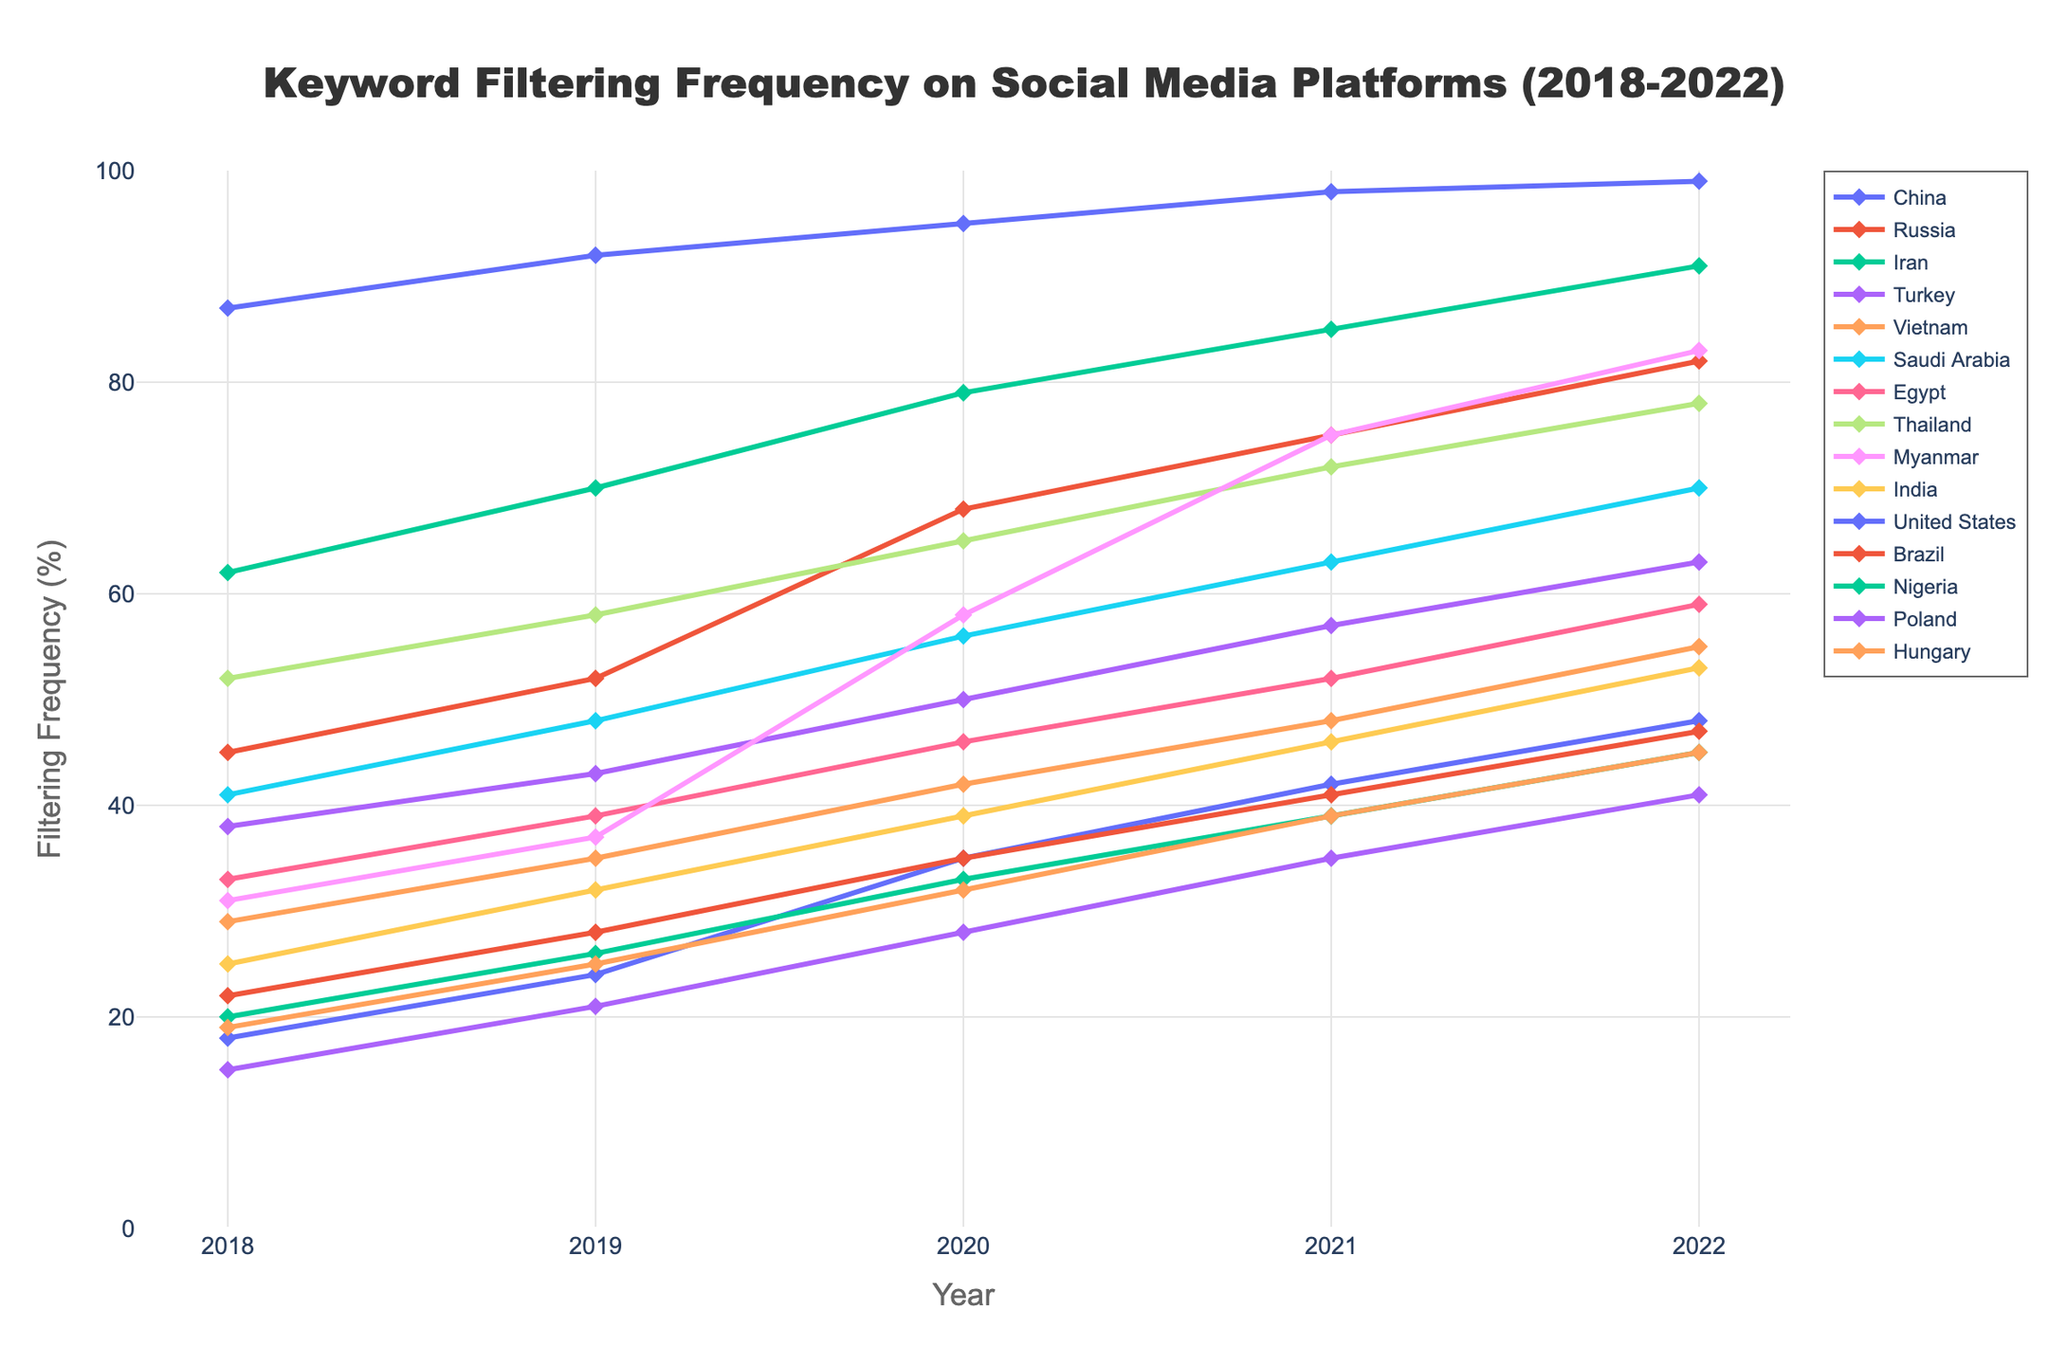What region had the highest keyword filtering frequency in 2022? By comparing the filtering frequency data for all regions in 2022, China had the highest at 99%.
Answer: China Which region showed the most significant increase in keyword filtering frequency from 2018 to 2022? Calculate the difference in filtering frequencies from 2018 to 2022 for all regions. Myanmar showed the largest increase, from 31% to 83%.
Answer: Myanmar What is the average keyword filtering frequency across all regions in 2019? Sum the keyword filtering frequencies for all regions in 2019 and divide by the number of regions. (92+52+70+43+35+48+39+58+37+32+24+28+26+21+25) / 15 = 46.27%
Answer: 46.27% Which platform in Vietnam had a steady increase in keyword filtering frequency over the years? Reviewing Vietnam's data shows that Facebook consistently increased from 29% in 2018 to 55% in 2022.
Answer: Facebook In which year did Thailand's keyword filtering frequency on the Line platform reach 65%? By checking the data for Thailand, its filtering frequency on the Line platform was 65% in 2020.
Answer: 2020 How much did the filtering frequency for 'Misinformation' on Twitter in the United States increase from 2018 to 2022? By subtracting the 2018 frequency from the 2022 frequency for 'Misinformation' on Twitter in the United States: 48% - 18% = 30%.
Answer: 30% Which regions had a keyword filtering frequency that exceeded 50% for the first time in 2020? For 2020, regions with frequencies above 50% for the first time are Russia (68%), Turkey (50%), and Thailand (65%).
Answer: Russia, Turkey, and Thailand Between 2018 and 2022, which region experienced the lowest increase in filtering frequency? Calculate the frequency increases for each region over the 5 years and find the smallest one, which is for Poland (41% - 15% = 26%).
Answer: Poland 